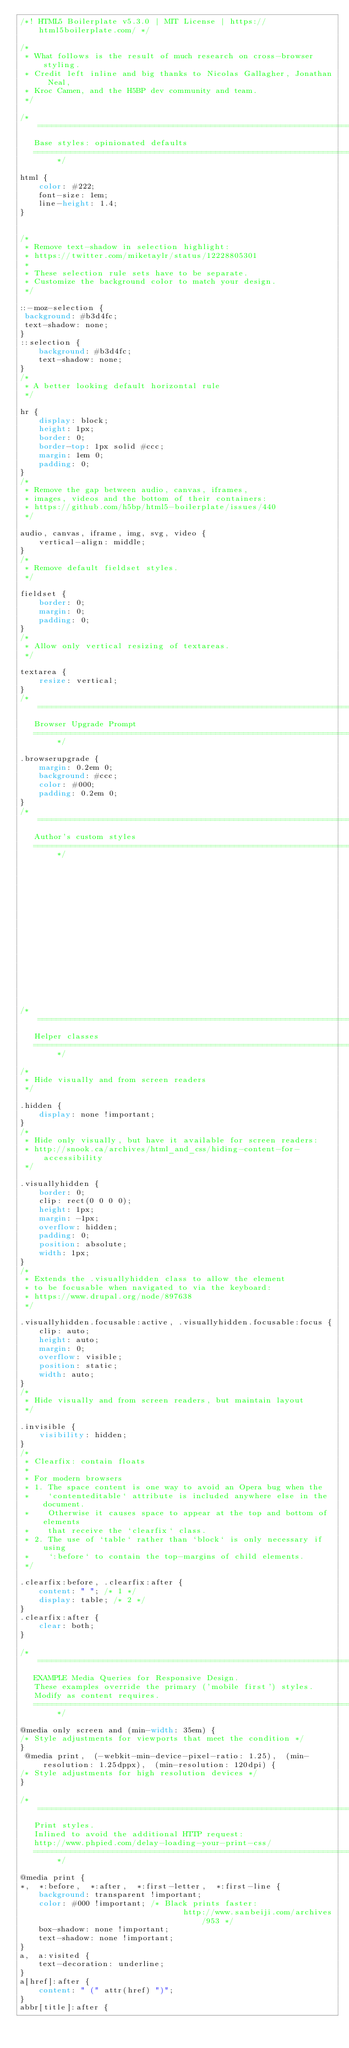<code> <loc_0><loc_0><loc_500><loc_500><_CSS_>/*! HTML5 Boilerplate v5.3.0 | MIT License | https://html5boilerplate.com/ */

/*
 * What follows is the result of much research on cross-browser styling.
 * Credit left inline and big thanks to Nicolas Gallagher, Jonathan Neal,
 * Kroc Camen, and the H5BP dev community and team.
 */

/* ==========================================================================
   Base styles: opinionated defaults
   ========================================================================== */

html {
	color: #222;
	font-size: 1em;
	line-height: 1.4;
}


/*
 * Remove text-shadow in selection highlight:
 * https://twitter.com/miketaylr/status/12228805301
 *
 * These selection rule sets have to be separate.
 * Customize the background color to match your design.
 */

::-moz-selection {
 background: #b3d4fc;
 text-shadow: none;
}
::selection {
	background: #b3d4fc;
	text-shadow: none;
}
/*
 * A better looking default horizontal rule
 */

hr {
	display: block;
	height: 1px;
	border: 0;
	border-top: 1px solid #ccc;
	margin: 1em 0;
	padding: 0;
}
/*
 * Remove the gap between audio, canvas, iframes,
 * images, videos and the bottom of their containers:
 * https://github.com/h5bp/html5-boilerplate/issues/440
 */

audio, canvas, iframe, img, svg, video {
	vertical-align: middle;
}
/*
 * Remove default fieldset styles.
 */

fieldset {
	border: 0;
	margin: 0;
	padding: 0;
}
/*
 * Allow only vertical resizing of textareas.
 */

textarea {
	resize: vertical;
}
/* ==========================================================================
   Browser Upgrade Prompt
   ========================================================================== */

.browserupgrade {
	margin: 0.2em 0;
	background: #ccc;
	color: #000;
	padding: 0.2em 0;
}
/* ==========================================================================
   Author's custom styles
   ========================================================================== */

















/* ==========================================================================
   Helper classes
   ========================================================================== */

/*
 * Hide visually and from screen readers
 */

.hidden {
	display: none !important;
}
/*
 * Hide only visually, but have it available for screen readers:
 * http://snook.ca/archives/html_and_css/hiding-content-for-accessibility
 */

.visuallyhidden {
	border: 0;
	clip: rect(0 0 0 0);
	height: 1px;
	margin: -1px;
	overflow: hidden;
	padding: 0;
	position: absolute;
	width: 1px;
}
/*
 * Extends the .visuallyhidden class to allow the element
 * to be focusable when navigated to via the keyboard:
 * https://www.drupal.org/node/897638
 */

.visuallyhidden.focusable:active, .visuallyhidden.focusable:focus {
	clip: auto;
	height: auto;
	margin: 0;
	overflow: visible;
	position: static;
	width: auto;
}
/*
 * Hide visually and from screen readers, but maintain layout
 */

.invisible {
	visibility: hidden;
}
/*
 * Clearfix: contain floats
 *
 * For modern browsers
 * 1. The space content is one way to avoid an Opera bug when the
 *    `contenteditable` attribute is included anywhere else in the document.
 *    Otherwise it causes space to appear at the top and bottom of elements
 *    that receive the `clearfix` class.
 * 2. The use of `table` rather than `block` is only necessary if using
 *    `:before` to contain the top-margins of child elements.
 */

.clearfix:before, .clearfix:after {
	content: " "; /* 1 */
	display: table; /* 2 */
}
.clearfix:after {
	clear: both;
}

/* ==========================================================================
   EXAMPLE Media Queries for Responsive Design.
   These examples override the primary ('mobile first') styles.
   Modify as content requires.
   ========================================================================== */

@media only screen and (min-width: 35em) {
/* Style adjustments for viewports that meet the condition */
}
 @media print,  (-webkit-min-device-pixel-ratio: 1.25),  (min-resolution: 1.25dppx),  (min-resolution: 120dpi) {
/* Style adjustments for high resolution devices */
}

/* ==========================================================================
   Print styles.
   Inlined to avoid the additional HTTP request:
   http://www.phpied.com/delay-loading-your-print-css/
   ========================================================================== */

@media print {
*,  *:before,  *:after,  *:first-letter,  *:first-line {
	background: transparent !important;
	color: #000 !important; /* Black prints faster:
                                   http://www.sanbeiji.com/archives/953 */
	box-shadow: none !important;
	text-shadow: none !important;
}
a,  a:visited {
	text-decoration: underline;
}
a[href]:after {
	content: " (" attr(href) ")";
}
abbr[title]:after {</code> 